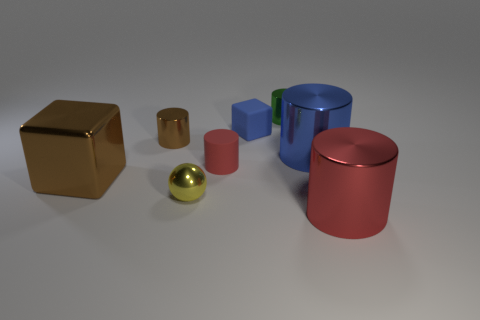Subtract all purple cylinders. Subtract all brown balls. How many cylinders are left? 5 Add 1 big red metallic things. How many objects exist? 9 Subtract all cylinders. How many objects are left? 3 Add 5 small blocks. How many small blocks exist? 6 Subtract 0 red blocks. How many objects are left? 8 Subtract all big green rubber blocks. Subtract all small green metallic objects. How many objects are left? 7 Add 2 tiny green cylinders. How many tiny green cylinders are left? 3 